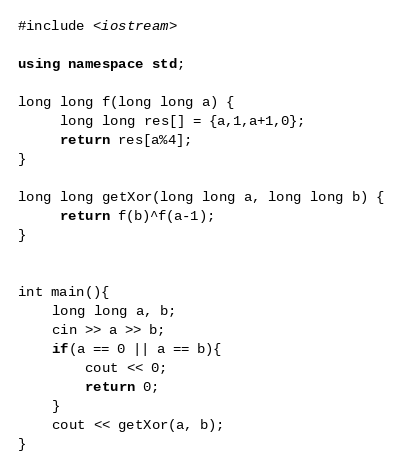<code> <loc_0><loc_0><loc_500><loc_500><_C++_>#include <iostream>

using namespace std;

long long f(long long a) {
     long long res[] = {a,1,a+1,0};
     return res[a%4];
}

long long getXor(long long a, long long b) {
     return f(b)^f(a-1);
}


int main(){
    long long a, b;
    cin >> a >> b;
    if(a == 0 || a == b){
        cout << 0;
        return 0;
    }
    cout << getXor(a, b);
}
</code> 